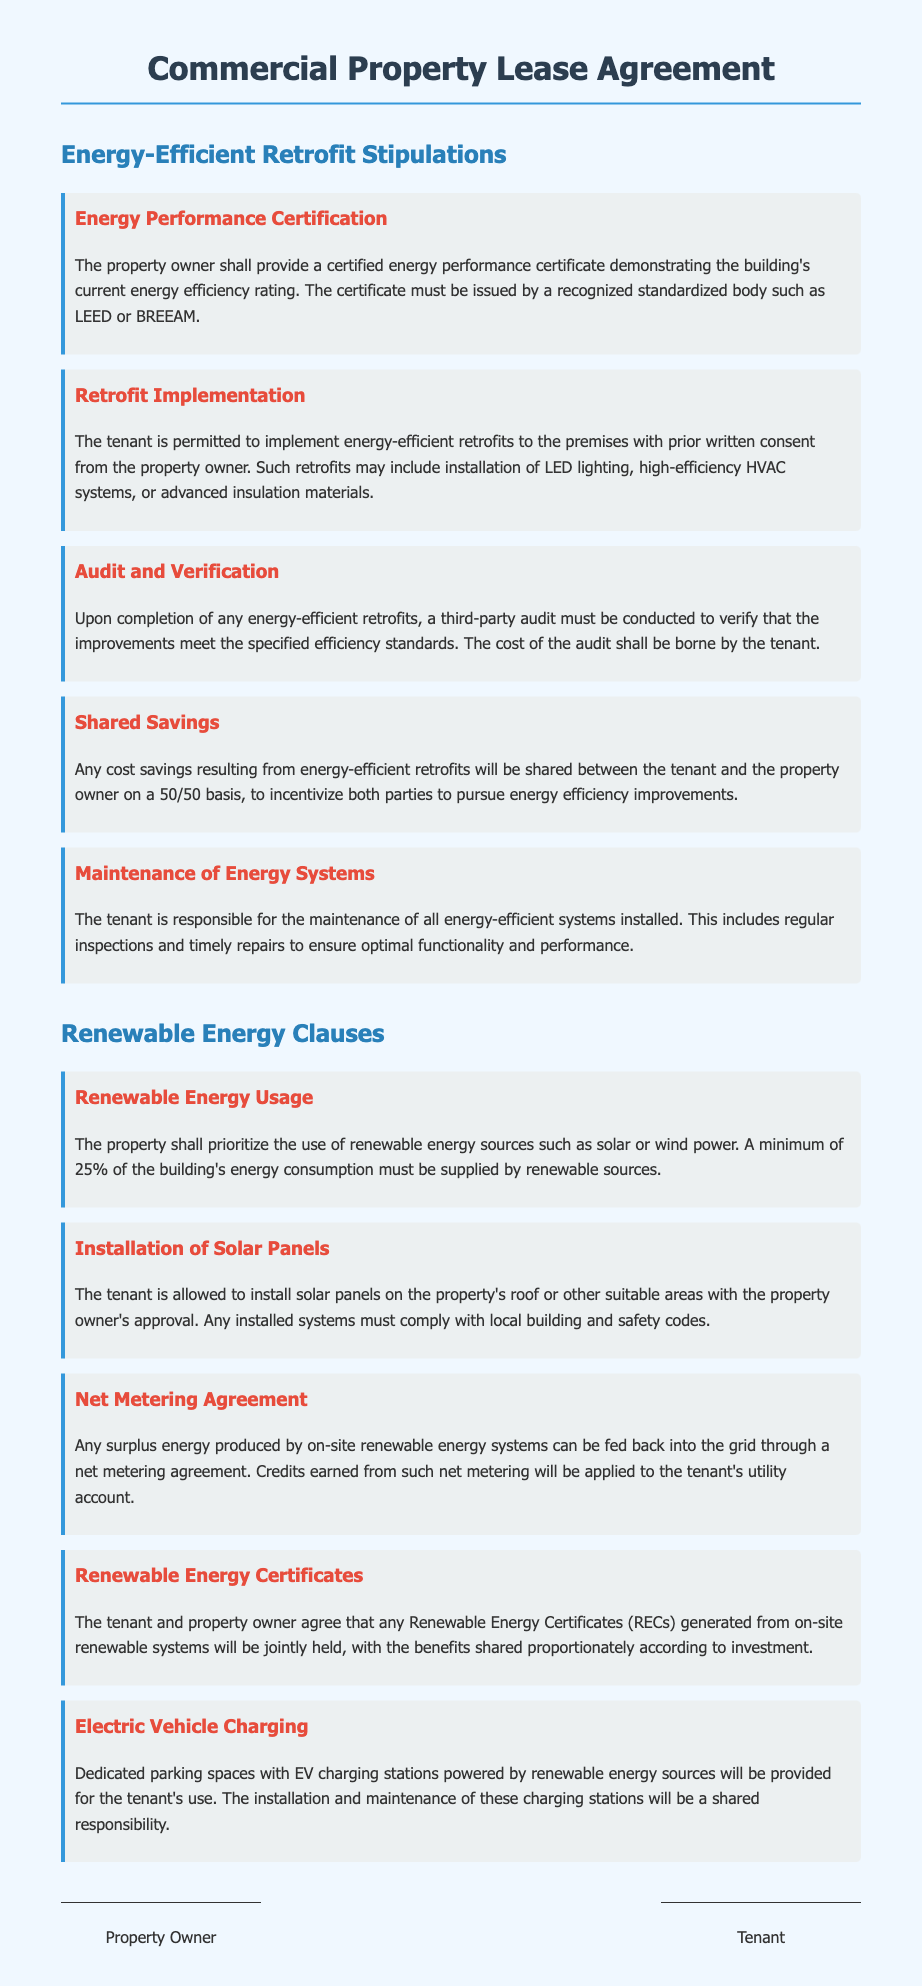What certification must the property owner provide? The property owner must provide a certified energy performance certificate demonstrating the building's current energy efficiency rating.
Answer: energy performance certificate What percentage of the building's energy consumption must be supplied by renewable sources? The document stipulates that a minimum of 25% of the building's energy consumption must come from renewable sources.
Answer: 25% Who bears the cost of the third-party audit for energy-efficient retrofits? According to the clause, the tenant is responsible for bearing the cost of the audit.
Answer: tenant Which energy-efficient system's maintenance is the tenant responsible for? The tenant is required to maintain all energy-efficient systems installed in the premises.
Answer: energy-efficient systems What is the sharing ratio for cost savings from energy-efficient retrofits? The document states that any cost savings will be shared between the tenant and the property owner on a 50/50 basis.
Answer: 50/50 Can the tenant install solar panels on the property? The document allows the tenant to install solar panels with the property owner's approval.
Answer: yes What role do Renewable Energy Certificates (RECs) play in this lease? The RECs generated from on-site renewable systems will be jointly held by the tenant and property owner.
Answer: jointly held What type of vehicle charging stations will be provided? The lease states that dedicated parking spaces with EV charging stations powered by renewable energy sources will be provided.
Answer: EV charging stations What must be included in the installation of energy-efficient retrofits? The tenant's installation of energy-efficient retrofits must include prior written consent from the property owner.
Answer: prior written consent 